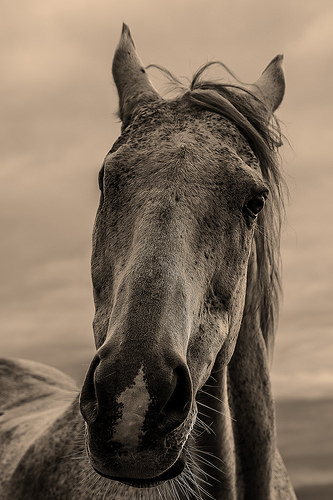<image>
Can you confirm if the horse is in the water? No. The horse is not contained within the water. These objects have a different spatial relationship. 